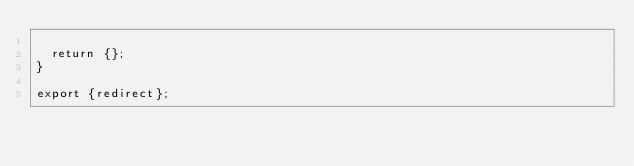<code> <loc_0><loc_0><loc_500><loc_500><_JavaScript_>
  return {};
}

export {redirect};
</code> 